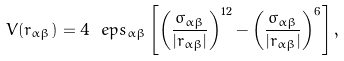Convert formula to latex. <formula><loc_0><loc_0><loc_500><loc_500>V ( r _ { \alpha \beta } ) = 4 \ e p s _ { \alpha \beta } \left [ \left ( \frac { \sigma _ { \alpha \beta } } { | r _ { \alpha \beta } | } \right ) ^ { 1 2 } - \left ( \frac { \sigma _ { \alpha \beta } } { | r _ { \alpha \beta } | } \right ) ^ { 6 } \right ] ,</formula> 